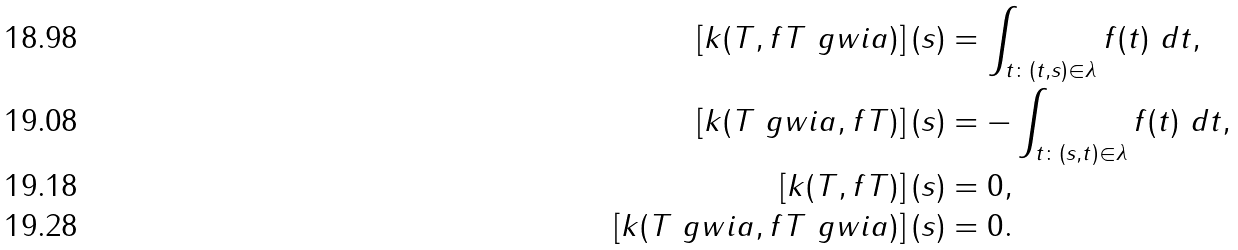Convert formula to latex. <formula><loc_0><loc_0><loc_500><loc_500>\left [ k ( T , f T \ g w i a ) \right ] ( s ) & = \int _ { t \colon ( t , s ) \in \lambda } f ( t ) \ d t , \\ \left [ k ( T \ g w i a , f T ) \right ] ( s ) & = - \int _ { t \colon ( s , t ) \in \lambda } f ( t ) \ d t , \\ \left [ k ( T , f T ) \right ] ( s ) & = 0 , \\ \left [ k ( T \ g w i a , f T \ g w i a ) \right ] ( s ) & = 0 .</formula> 